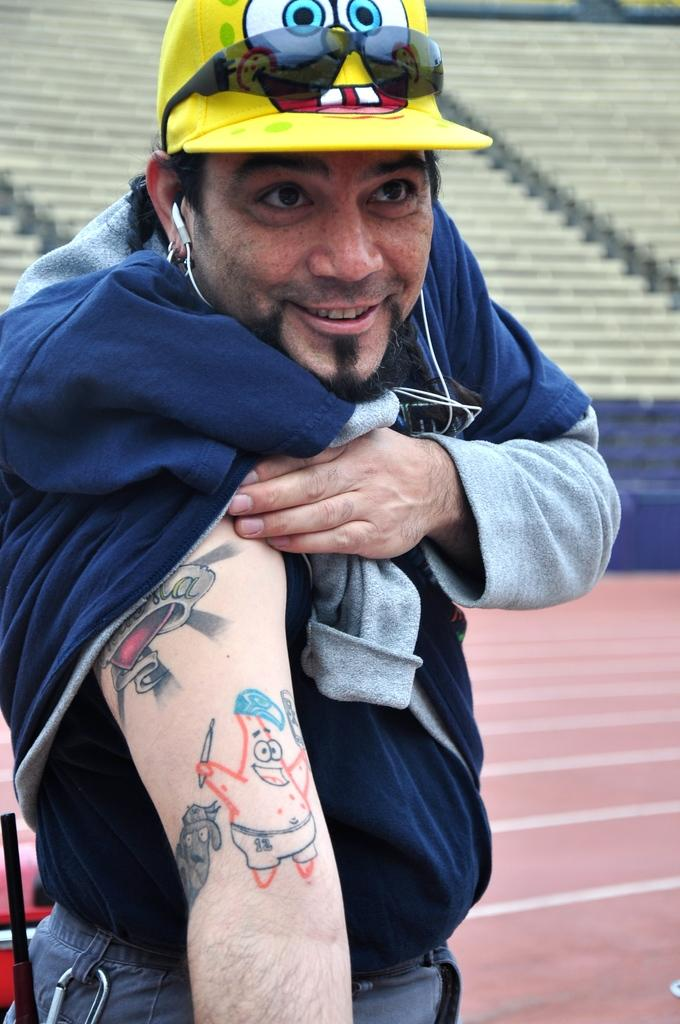Who is present in the image? There is a person in the image. What is the person doing in the image? The person is standing on the ground. What accessories is the person wearing in the image? The person is wearing a hat, glasses, and a headset. What can be seen in the background of the image? There is stadium seating visible in the background of the image. What type of pancake does the person in the image prefer? There is no information about the person's pancake preferences in the image, as it does not contain any pancakes. 